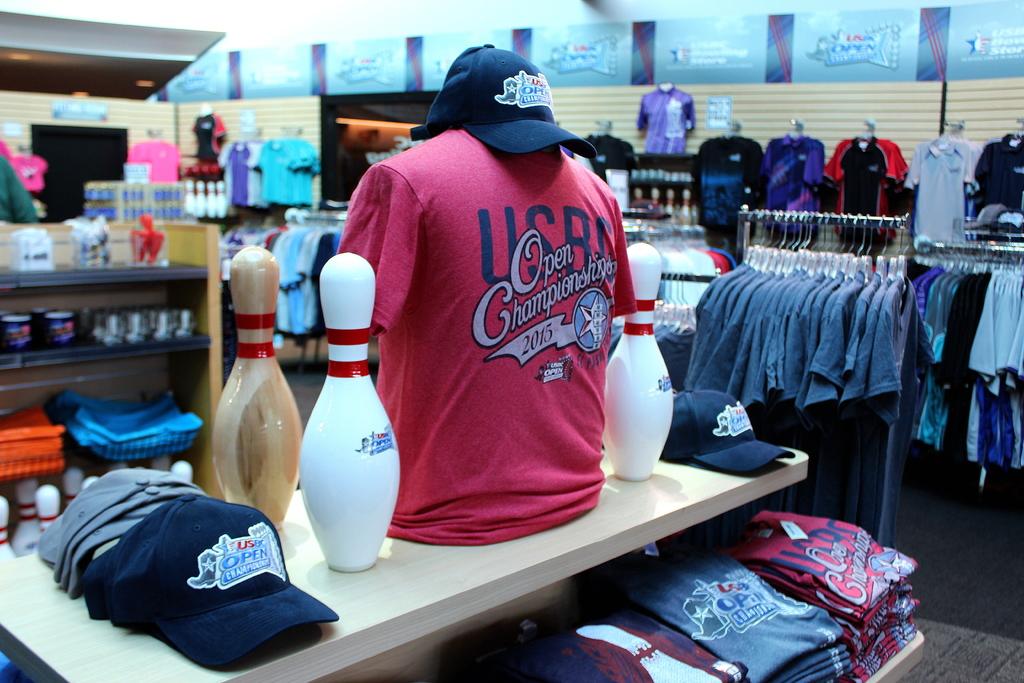What year is the red championship shirt for?
Provide a short and direct response. 2015. Is the championship open or closed?
Keep it short and to the point. Open. 